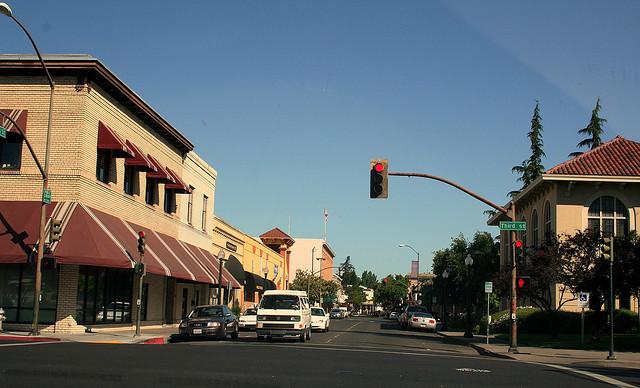Is it likely this is an ordinary day in this village?
Keep it brief. Yes. What color are the traffic signals?
Be succinct. Red. Night time or day time?
Concise answer only. Day. Was this picture taken from inside a car?
Short answer required. Yes. Are any green traffic lights visible?
Answer briefly. No. How much longer will the red light be?
Quick response, please. 5 seconds. Is this building complete?
Keep it brief. Yes. Where is the town?
Quick response, please. Usa. 